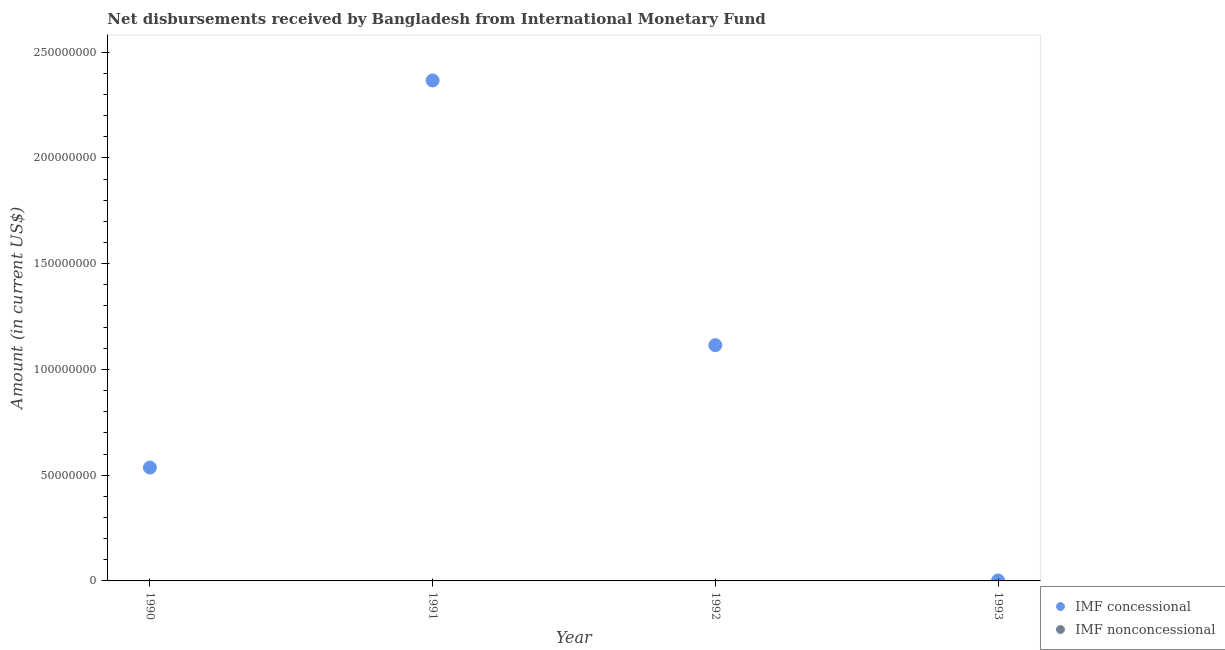How many different coloured dotlines are there?
Provide a succinct answer. 1. What is the net concessional disbursements from imf in 1992?
Your response must be concise. 1.11e+08. Across all years, what is the maximum net concessional disbursements from imf?
Make the answer very short. 2.37e+08. Across all years, what is the minimum net non concessional disbursements from imf?
Offer a very short reply. 0. What is the total net concessional disbursements from imf in the graph?
Your answer should be very brief. 4.02e+08. What is the difference between the net concessional disbursements from imf in 1991 and that in 1993?
Your answer should be very brief. 2.36e+08. What is the difference between the net concessional disbursements from imf in 1993 and the net non concessional disbursements from imf in 1992?
Offer a very short reply. 2.14e+05. What is the average net concessional disbursements from imf per year?
Your answer should be compact. 1.00e+08. What is the ratio of the net concessional disbursements from imf in 1990 to that in 1993?
Your answer should be very brief. 250.45. What is the difference between the highest and the second highest net concessional disbursements from imf?
Keep it short and to the point. 1.25e+08. What is the difference between the highest and the lowest net concessional disbursements from imf?
Your response must be concise. 2.36e+08. In how many years, is the net concessional disbursements from imf greater than the average net concessional disbursements from imf taken over all years?
Your response must be concise. 2. Does the net non concessional disbursements from imf monotonically increase over the years?
Provide a short and direct response. Yes. Is the net non concessional disbursements from imf strictly greater than the net concessional disbursements from imf over the years?
Offer a very short reply. No. Is the net concessional disbursements from imf strictly less than the net non concessional disbursements from imf over the years?
Give a very brief answer. No. How many dotlines are there?
Offer a very short reply. 1. How many years are there in the graph?
Provide a short and direct response. 4. What is the difference between two consecutive major ticks on the Y-axis?
Your answer should be very brief. 5.00e+07. Does the graph contain any zero values?
Offer a very short reply. Yes. How many legend labels are there?
Provide a short and direct response. 2. How are the legend labels stacked?
Ensure brevity in your answer.  Vertical. What is the title of the graph?
Your response must be concise. Net disbursements received by Bangladesh from International Monetary Fund. What is the label or title of the X-axis?
Provide a short and direct response. Year. What is the label or title of the Y-axis?
Offer a terse response. Amount (in current US$). What is the Amount (in current US$) in IMF concessional in 1990?
Ensure brevity in your answer.  5.36e+07. What is the Amount (in current US$) of IMF concessional in 1991?
Your response must be concise. 2.37e+08. What is the Amount (in current US$) of IMF nonconcessional in 1991?
Your response must be concise. 0. What is the Amount (in current US$) of IMF concessional in 1992?
Offer a terse response. 1.11e+08. What is the Amount (in current US$) of IMF concessional in 1993?
Provide a short and direct response. 2.14e+05. What is the Amount (in current US$) of IMF nonconcessional in 1993?
Offer a very short reply. 0. Across all years, what is the maximum Amount (in current US$) of IMF concessional?
Offer a terse response. 2.37e+08. Across all years, what is the minimum Amount (in current US$) in IMF concessional?
Provide a short and direct response. 2.14e+05. What is the total Amount (in current US$) of IMF concessional in the graph?
Offer a terse response. 4.02e+08. What is the difference between the Amount (in current US$) in IMF concessional in 1990 and that in 1991?
Your answer should be compact. -1.83e+08. What is the difference between the Amount (in current US$) in IMF concessional in 1990 and that in 1992?
Offer a terse response. -5.79e+07. What is the difference between the Amount (in current US$) in IMF concessional in 1990 and that in 1993?
Provide a short and direct response. 5.34e+07. What is the difference between the Amount (in current US$) of IMF concessional in 1991 and that in 1992?
Ensure brevity in your answer.  1.25e+08. What is the difference between the Amount (in current US$) of IMF concessional in 1991 and that in 1993?
Make the answer very short. 2.36e+08. What is the difference between the Amount (in current US$) of IMF concessional in 1992 and that in 1993?
Make the answer very short. 1.11e+08. What is the average Amount (in current US$) of IMF concessional per year?
Offer a very short reply. 1.00e+08. What is the ratio of the Amount (in current US$) of IMF concessional in 1990 to that in 1991?
Your response must be concise. 0.23. What is the ratio of the Amount (in current US$) in IMF concessional in 1990 to that in 1992?
Your answer should be very brief. 0.48. What is the ratio of the Amount (in current US$) in IMF concessional in 1990 to that in 1993?
Offer a very short reply. 250.45. What is the ratio of the Amount (in current US$) in IMF concessional in 1991 to that in 1992?
Give a very brief answer. 2.12. What is the ratio of the Amount (in current US$) of IMF concessional in 1991 to that in 1993?
Make the answer very short. 1105.72. What is the ratio of the Amount (in current US$) of IMF concessional in 1992 to that in 1993?
Provide a succinct answer. 520.86. What is the difference between the highest and the second highest Amount (in current US$) of IMF concessional?
Ensure brevity in your answer.  1.25e+08. What is the difference between the highest and the lowest Amount (in current US$) in IMF concessional?
Make the answer very short. 2.36e+08. 